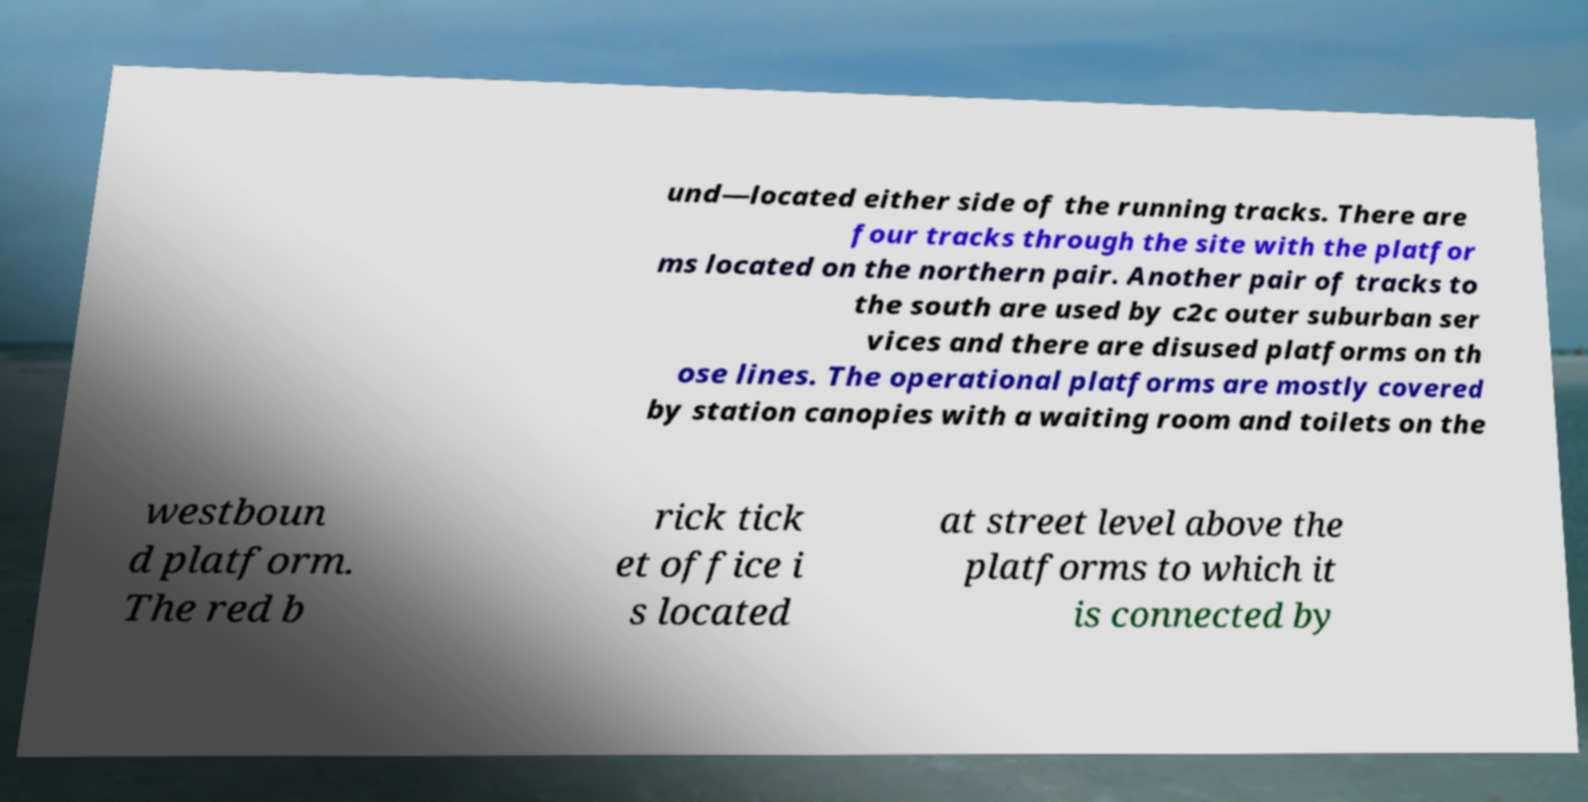Can you read and provide the text displayed in the image?This photo seems to have some interesting text. Can you extract and type it out for me? und—located either side of the running tracks. There are four tracks through the site with the platfor ms located on the northern pair. Another pair of tracks to the south are used by c2c outer suburban ser vices and there are disused platforms on th ose lines. The operational platforms are mostly covered by station canopies with a waiting room and toilets on the westboun d platform. The red b rick tick et office i s located at street level above the platforms to which it is connected by 